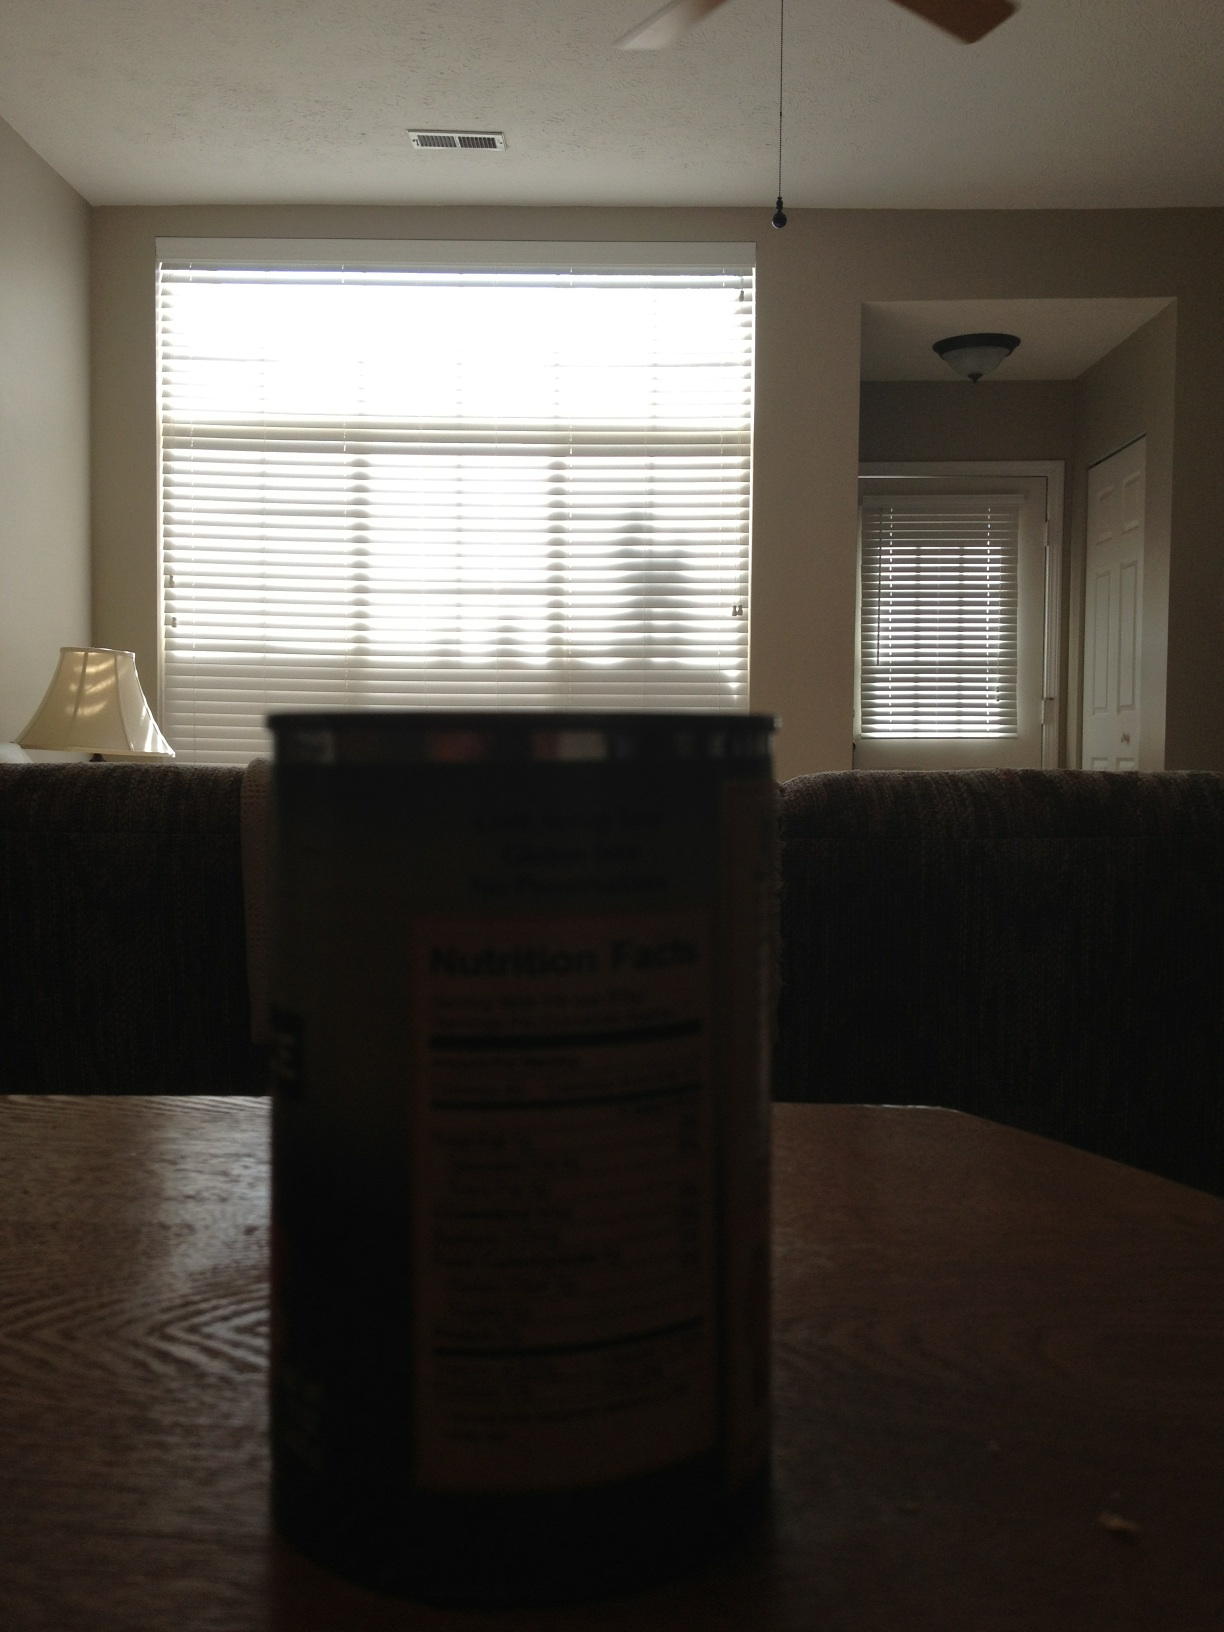What's a realistic daily scene that could occur in this room? A realistic scene could be a family gathering in the living room, sharing a meal prepared using ingredients from the can on the table. The room would be filled with laughter and conversation as natural light streams in through the blinds. 